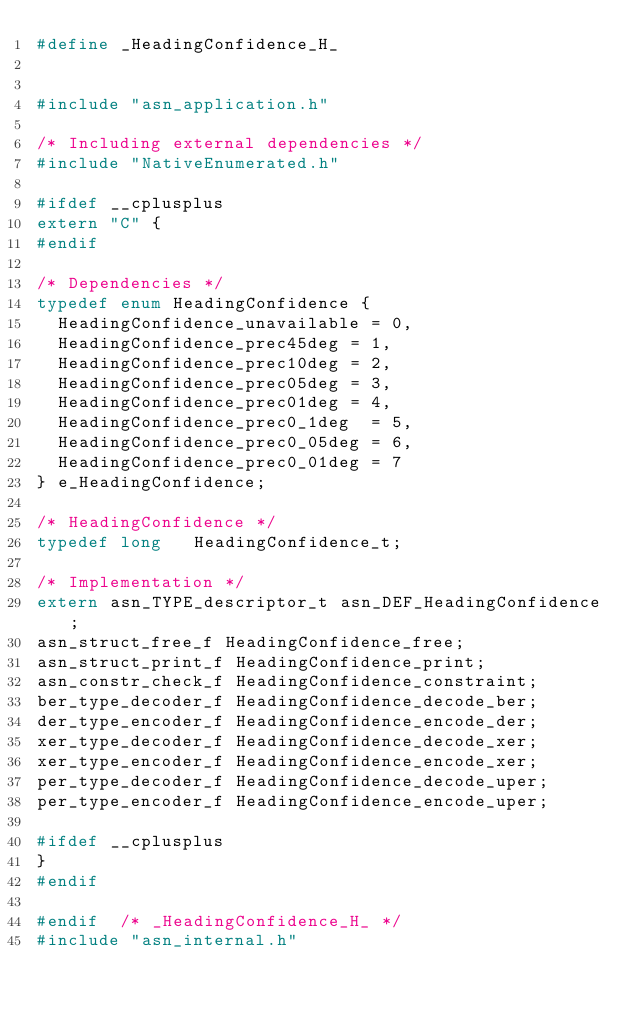<code> <loc_0><loc_0><loc_500><loc_500><_C_>#define	_HeadingConfidence_H_


#include "asn_application.h"

/* Including external dependencies */
#include "NativeEnumerated.h"

#ifdef __cplusplus
extern "C" {
#endif

/* Dependencies */
typedef enum HeadingConfidence {
	HeadingConfidence_unavailable	= 0,
	HeadingConfidence_prec45deg	= 1,
	HeadingConfidence_prec10deg	= 2,
	HeadingConfidence_prec05deg	= 3,
	HeadingConfidence_prec01deg	= 4,
	HeadingConfidence_prec0_1deg	= 5,
	HeadingConfidence_prec0_05deg	= 6,
	HeadingConfidence_prec0_01deg	= 7
} e_HeadingConfidence;

/* HeadingConfidence */
typedef long	 HeadingConfidence_t;

/* Implementation */
extern asn_TYPE_descriptor_t asn_DEF_HeadingConfidence;
asn_struct_free_f HeadingConfidence_free;
asn_struct_print_f HeadingConfidence_print;
asn_constr_check_f HeadingConfidence_constraint;
ber_type_decoder_f HeadingConfidence_decode_ber;
der_type_encoder_f HeadingConfidence_encode_der;
xer_type_decoder_f HeadingConfidence_decode_xer;
xer_type_encoder_f HeadingConfidence_encode_xer;
per_type_decoder_f HeadingConfidence_decode_uper;
per_type_encoder_f HeadingConfidence_encode_uper;

#ifdef __cplusplus
}
#endif

#endif	/* _HeadingConfidence_H_ */
#include "asn_internal.h"
</code> 